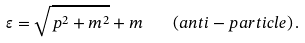<formula> <loc_0><loc_0><loc_500><loc_500>\varepsilon = \sqrt { p ^ { 2 } + m ^ { 2 } } + m \quad ( a n t i - p a r t i c l e ) \, .</formula> 